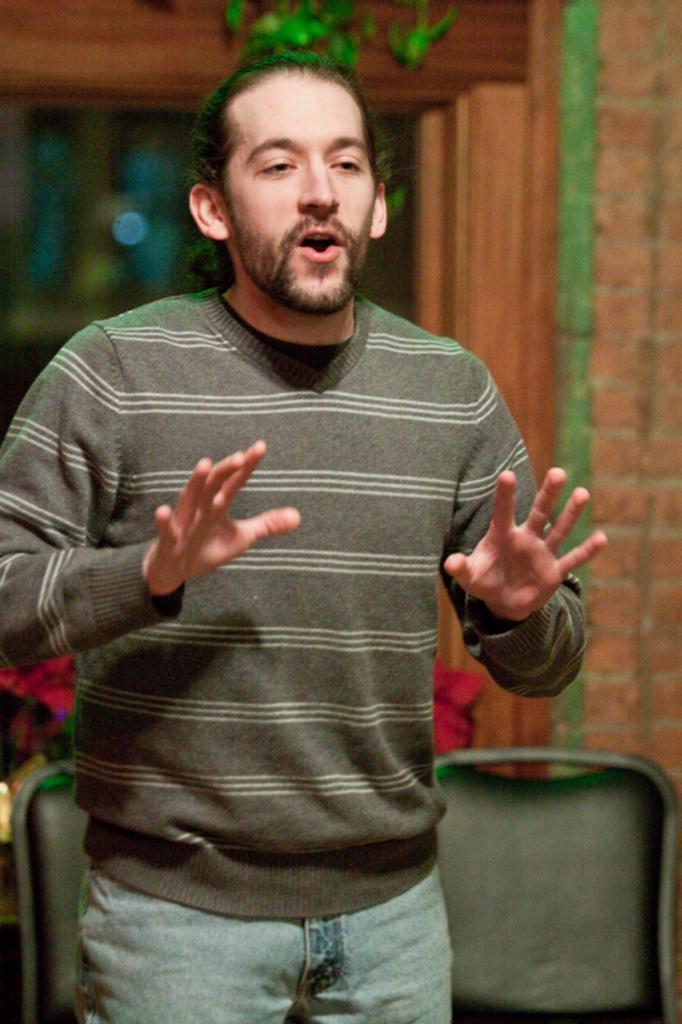How would you summarize this image in a sentence or two? In this image we can see a man who is wearing sweater with jeans. Behind him chairs and brick wall are there. 